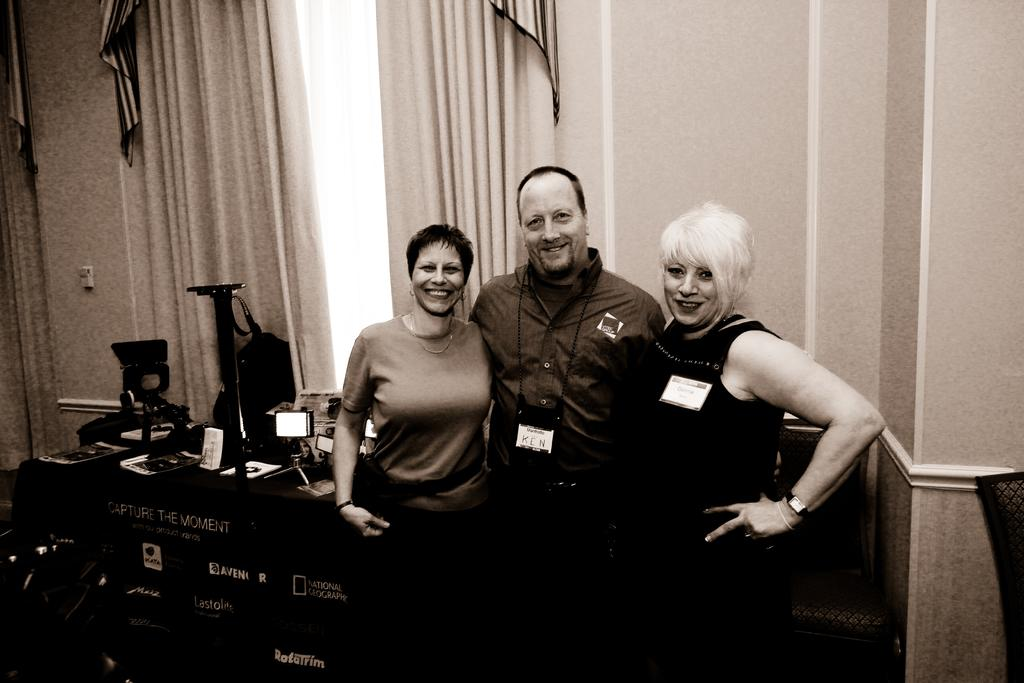How many people are present in the image? There are three people in the image. What are the people doing in the image? The people are standing and smiling. What can be seen on the table in the image? There are objects on the table. What is visible in the background of the image? There are curtains and a wall in the background of the image. What type of crate is being used by the queen in the image? There is no crate or queen present in the image. How does the image end? The image does not have an ending, as it is a still image and not a video or story. 